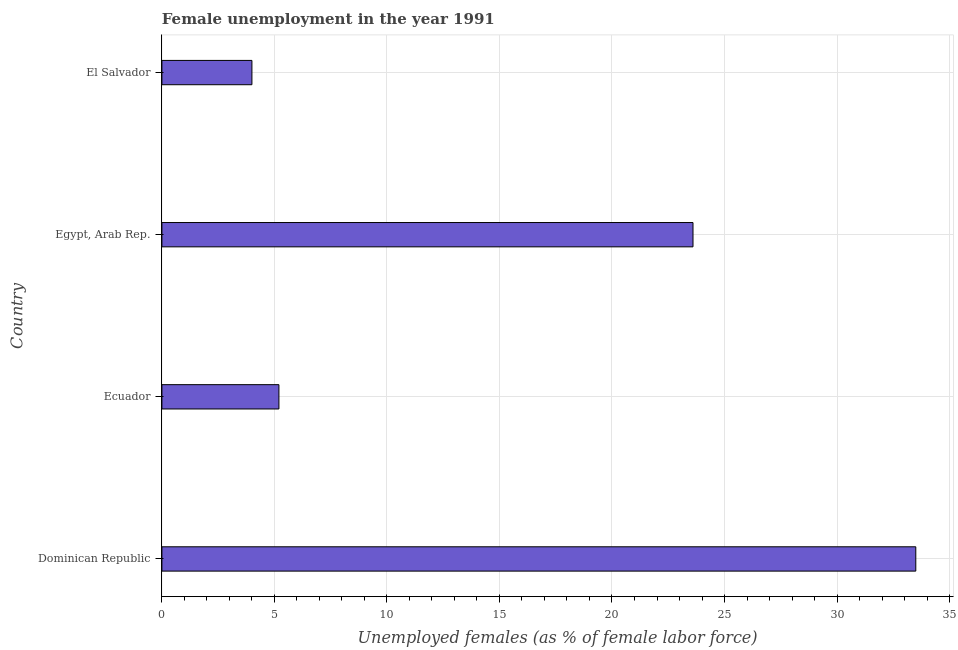Does the graph contain any zero values?
Offer a very short reply. No. What is the title of the graph?
Your answer should be compact. Female unemployment in the year 1991. What is the label or title of the X-axis?
Offer a very short reply. Unemployed females (as % of female labor force). Across all countries, what is the maximum unemployed females population?
Provide a short and direct response. 33.5. In which country was the unemployed females population maximum?
Provide a short and direct response. Dominican Republic. In which country was the unemployed females population minimum?
Offer a terse response. El Salvador. What is the sum of the unemployed females population?
Keep it short and to the point. 66.3. What is the difference between the unemployed females population in Dominican Republic and El Salvador?
Ensure brevity in your answer.  29.5. What is the average unemployed females population per country?
Offer a very short reply. 16.57. What is the median unemployed females population?
Ensure brevity in your answer.  14.4. What is the ratio of the unemployed females population in Ecuador to that in El Salvador?
Your answer should be compact. 1.3. Is the difference between the unemployed females population in Dominican Republic and El Salvador greater than the difference between any two countries?
Your answer should be very brief. Yes. What is the difference between the highest and the lowest unemployed females population?
Your answer should be compact. 29.5. How many bars are there?
Your answer should be compact. 4. Are all the bars in the graph horizontal?
Ensure brevity in your answer.  Yes. How many countries are there in the graph?
Give a very brief answer. 4. What is the difference between two consecutive major ticks on the X-axis?
Keep it short and to the point. 5. Are the values on the major ticks of X-axis written in scientific E-notation?
Offer a very short reply. No. What is the Unemployed females (as % of female labor force) of Dominican Republic?
Your response must be concise. 33.5. What is the Unemployed females (as % of female labor force) of Ecuador?
Make the answer very short. 5.2. What is the Unemployed females (as % of female labor force) of Egypt, Arab Rep.?
Give a very brief answer. 23.6. What is the Unemployed females (as % of female labor force) in El Salvador?
Give a very brief answer. 4. What is the difference between the Unemployed females (as % of female labor force) in Dominican Republic and Ecuador?
Ensure brevity in your answer.  28.3. What is the difference between the Unemployed females (as % of female labor force) in Dominican Republic and Egypt, Arab Rep.?
Provide a short and direct response. 9.9. What is the difference between the Unemployed females (as % of female labor force) in Dominican Republic and El Salvador?
Make the answer very short. 29.5. What is the difference between the Unemployed females (as % of female labor force) in Ecuador and Egypt, Arab Rep.?
Your answer should be very brief. -18.4. What is the difference between the Unemployed females (as % of female labor force) in Egypt, Arab Rep. and El Salvador?
Provide a short and direct response. 19.6. What is the ratio of the Unemployed females (as % of female labor force) in Dominican Republic to that in Ecuador?
Make the answer very short. 6.44. What is the ratio of the Unemployed females (as % of female labor force) in Dominican Republic to that in Egypt, Arab Rep.?
Your response must be concise. 1.42. What is the ratio of the Unemployed females (as % of female labor force) in Dominican Republic to that in El Salvador?
Make the answer very short. 8.38. What is the ratio of the Unemployed females (as % of female labor force) in Ecuador to that in Egypt, Arab Rep.?
Give a very brief answer. 0.22. What is the ratio of the Unemployed females (as % of female labor force) in Egypt, Arab Rep. to that in El Salvador?
Your response must be concise. 5.9. 